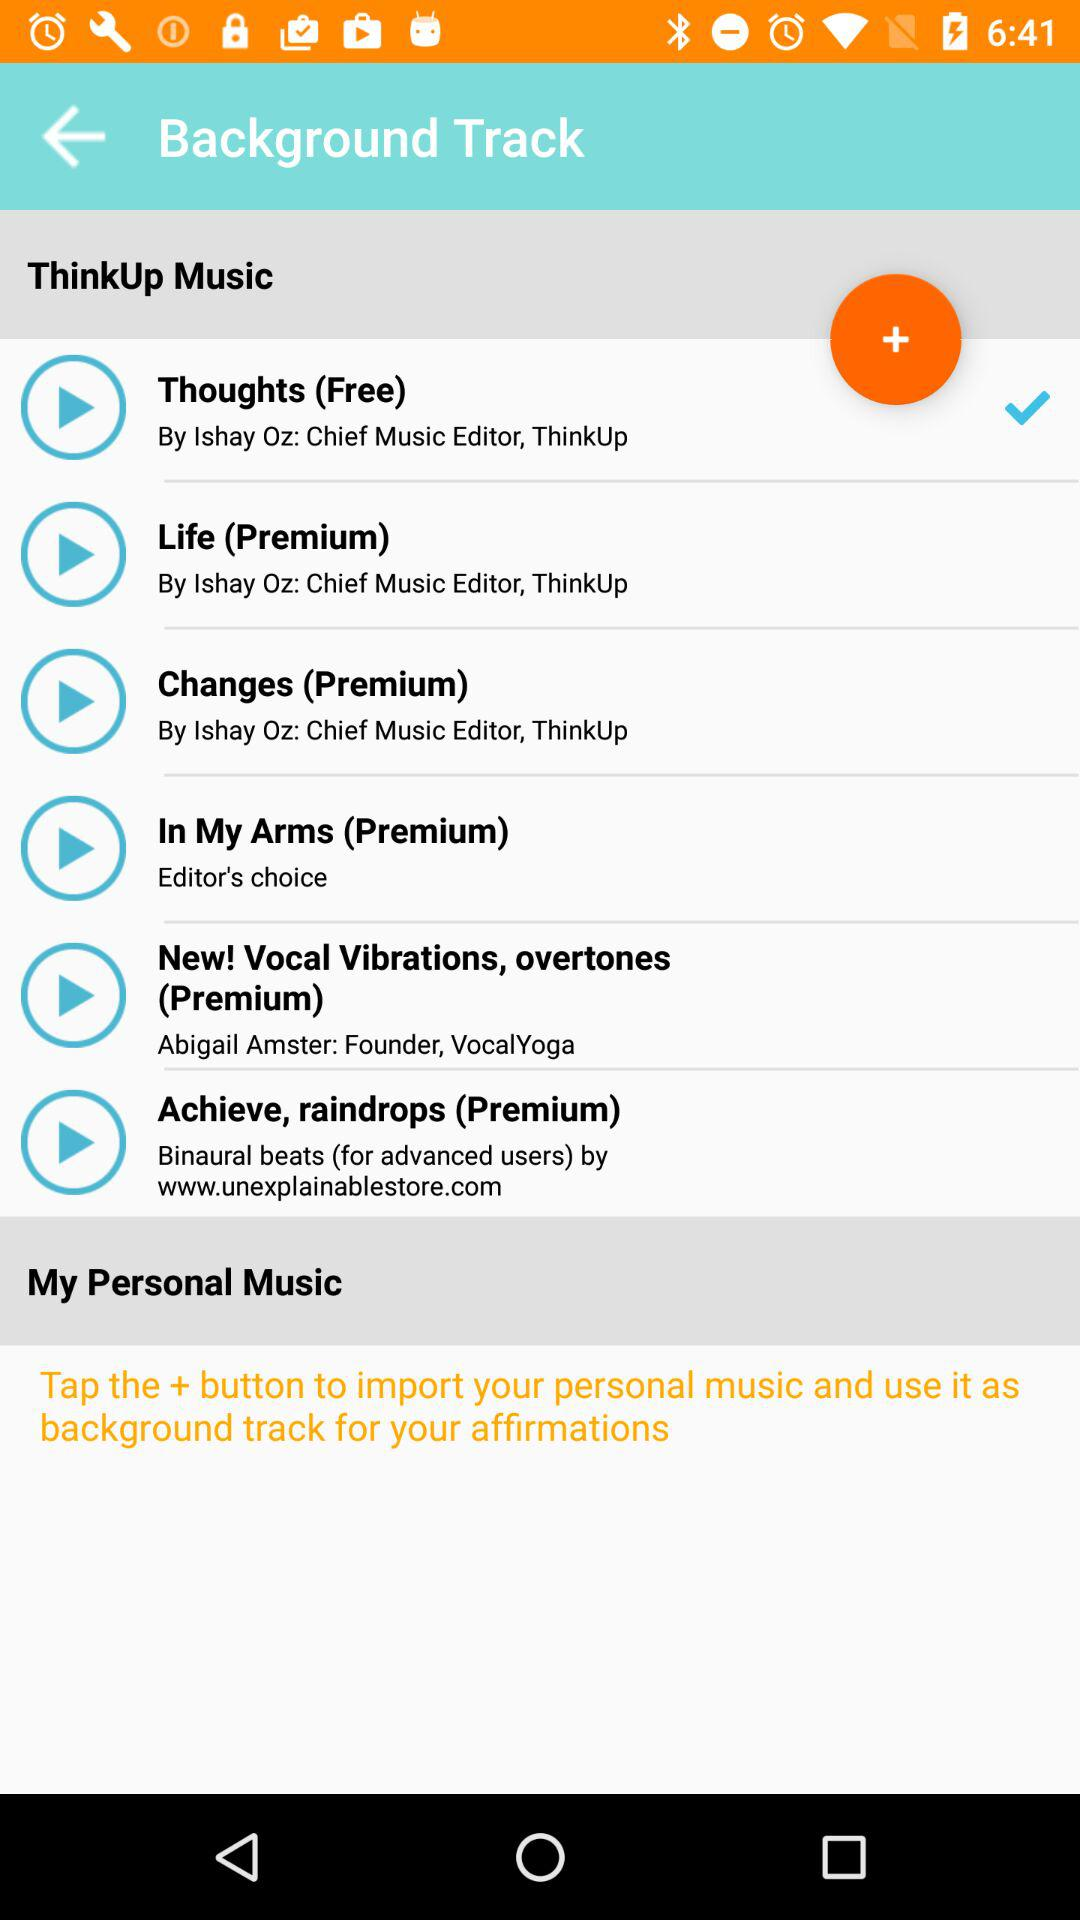What are the names of the free songs? The name of the free song is "Thoughts". 